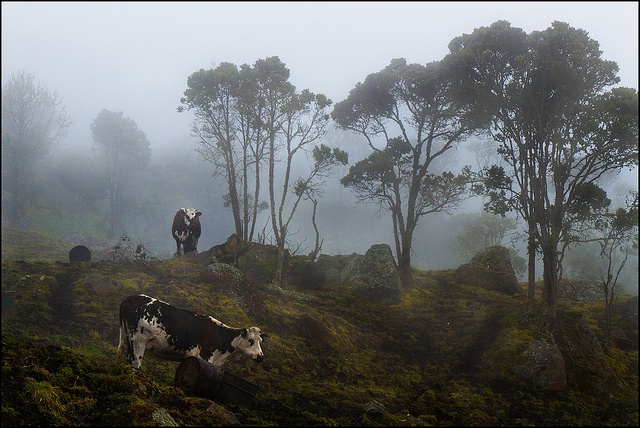Describe the objects in this image and their specific colors. I can see cow in black and gray tones and cow in black, gray, and darkgray tones in this image. 